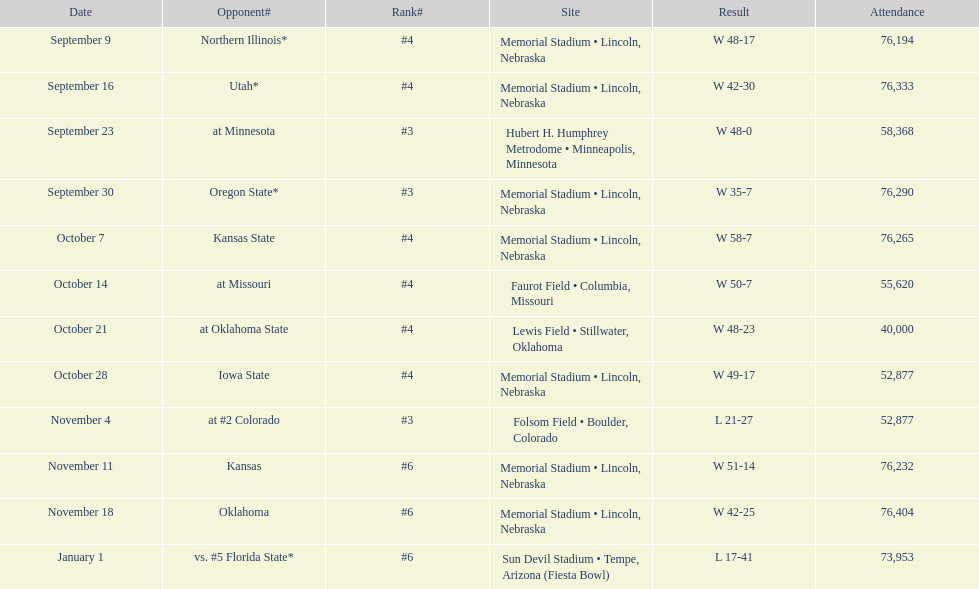When is the first game? September 9. 